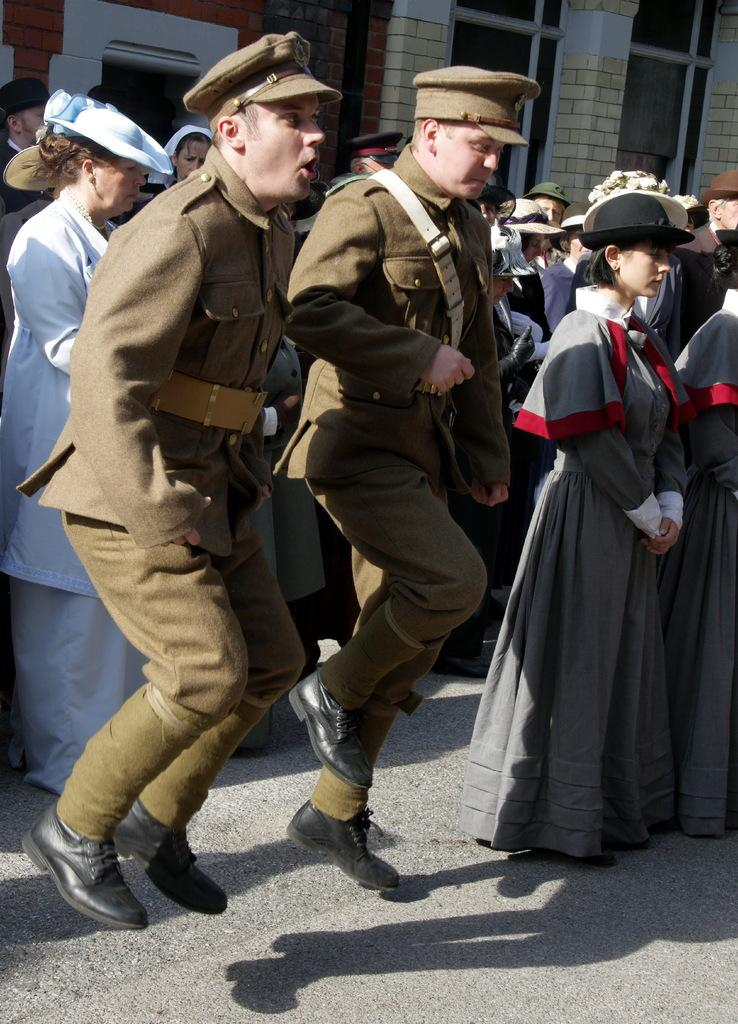How many people are in the group shown in the image? There is a group of people in the image. What are some of the men in the group wearing? Some men in the group are wearing hats, and some are wearing uniforms. What can be seen in the background of the image? There are buildings in the background of the image. What type of yard can be seen in the image? There is no yard present in the image; it features a group of people and buildings in the background. 